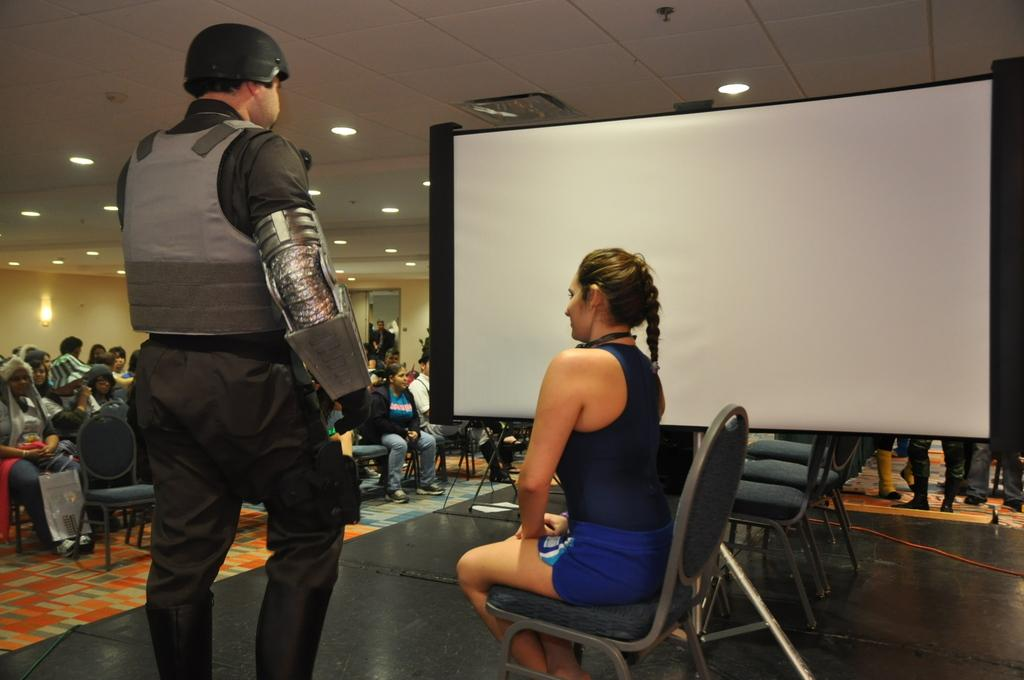What is located on top of the structure in the image? There are lights on top in the image. What are the people in the image doing? People are sitting on chairs in the image. What can be seen on the stage in the image? There is a screen on the stage in the image. Are there any chairs on the stage? Yes, there are chairs on the stage in the image. Are there people present on the stage? Yes, people are present on the stage in the image. What type of metal is used to create the string instruments played by the people on the stage? There is no mention of string instruments or metal in the image. What is the aftermath of the event depicted in the image? The image does not depict an event or its aftermath; it simply shows a stage with people and chairs. 